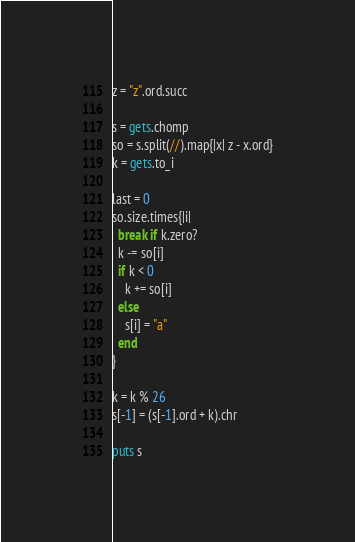Convert code to text. <code><loc_0><loc_0><loc_500><loc_500><_Ruby_>z = "z".ord.succ

s = gets.chomp
so = s.split(//).map{|x| z - x.ord}
k = gets.to_i

last = 0
so.size.times{|i|
  break if k.zero?
  k -= so[i]
  if k < 0
    k += so[i]
  else
    s[i] = "a"
  end
}

k = k % 26
s[-1] = (s[-1].ord + k).chr

puts s



</code> 